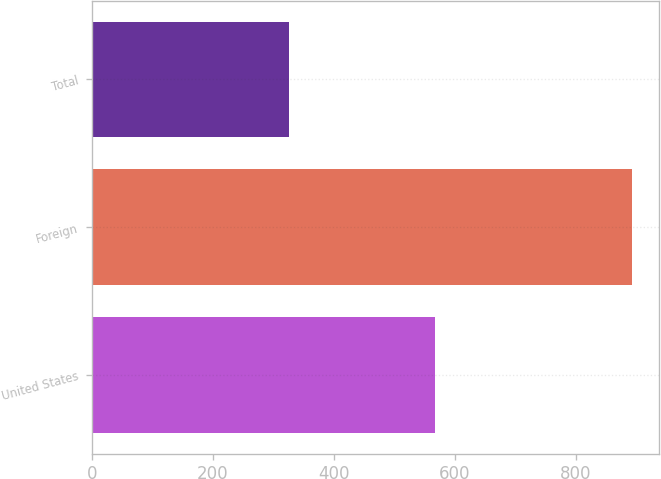Convert chart to OTSL. <chart><loc_0><loc_0><loc_500><loc_500><bar_chart><fcel>United States<fcel>Foreign<fcel>Total<nl><fcel>567<fcel>893<fcel>326<nl></chart> 